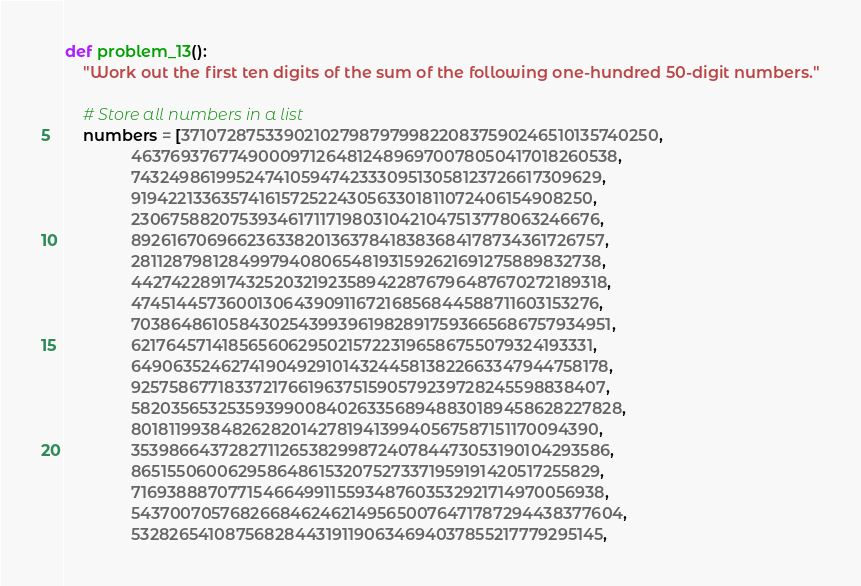<code> <loc_0><loc_0><loc_500><loc_500><_Python_>def problem_13():
    "Work out the first ten digits of the sum of the following one-hundred 50-digit numbers."

    # Store all numbers in a list
    numbers = [37107287533902102798797998220837590246510135740250,
               46376937677490009712648124896970078050417018260538,
               74324986199524741059474233309513058123726617309629,
               91942213363574161572522430563301811072406154908250,
               23067588207539346171171980310421047513778063246676,
               89261670696623633820136378418383684178734361726757,
               28112879812849979408065481931592621691275889832738,
               44274228917432520321923589422876796487670272189318,
               47451445736001306439091167216856844588711603153276,
               70386486105843025439939619828917593665686757934951,
               62176457141856560629502157223196586755079324193331,
               64906352462741904929101432445813822663347944758178,
               92575867718337217661963751590579239728245598838407,
               58203565325359399008402633568948830189458628227828,
               80181199384826282014278194139940567587151170094390,
               35398664372827112653829987240784473053190104293586,
               86515506006295864861532075273371959191420517255829,
               71693888707715466499115593487603532921714970056938,
               54370070576826684624621495650076471787294438377604,
               53282654108756828443191190634694037855217779295145,</code> 